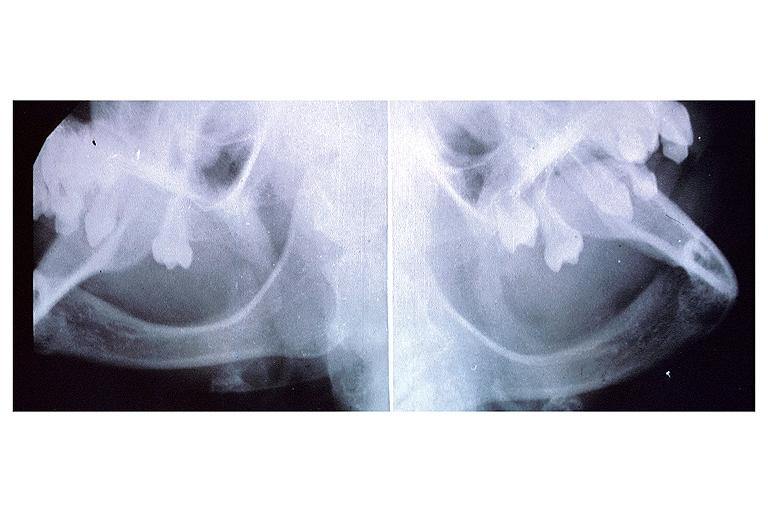does carcinomatosis endometrium primary show anhidrotic ectodermal dysplasia?
Answer the question using a single word or phrase. No 